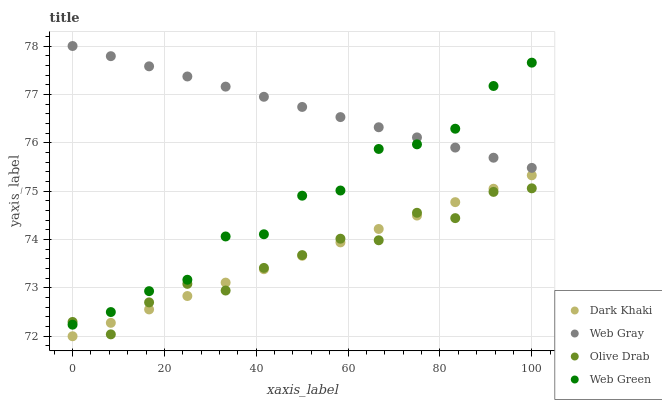Does Olive Drab have the minimum area under the curve?
Answer yes or no. Yes. Does Web Gray have the maximum area under the curve?
Answer yes or no. Yes. Does Web Green have the minimum area under the curve?
Answer yes or no. No. Does Web Green have the maximum area under the curve?
Answer yes or no. No. Is Web Gray the smoothest?
Answer yes or no. Yes. Is Web Green the roughest?
Answer yes or no. Yes. Is Web Green the smoothest?
Answer yes or no. No. Is Web Gray the roughest?
Answer yes or no. No. Does Dark Khaki have the lowest value?
Answer yes or no. Yes. Does Web Green have the lowest value?
Answer yes or no. No. Does Web Gray have the highest value?
Answer yes or no. Yes. Does Web Green have the highest value?
Answer yes or no. No. Is Dark Khaki less than Web Gray?
Answer yes or no. Yes. Is Web Gray greater than Olive Drab?
Answer yes or no. Yes. Does Web Green intersect Olive Drab?
Answer yes or no. Yes. Is Web Green less than Olive Drab?
Answer yes or no. No. Is Web Green greater than Olive Drab?
Answer yes or no. No. Does Dark Khaki intersect Web Gray?
Answer yes or no. No. 